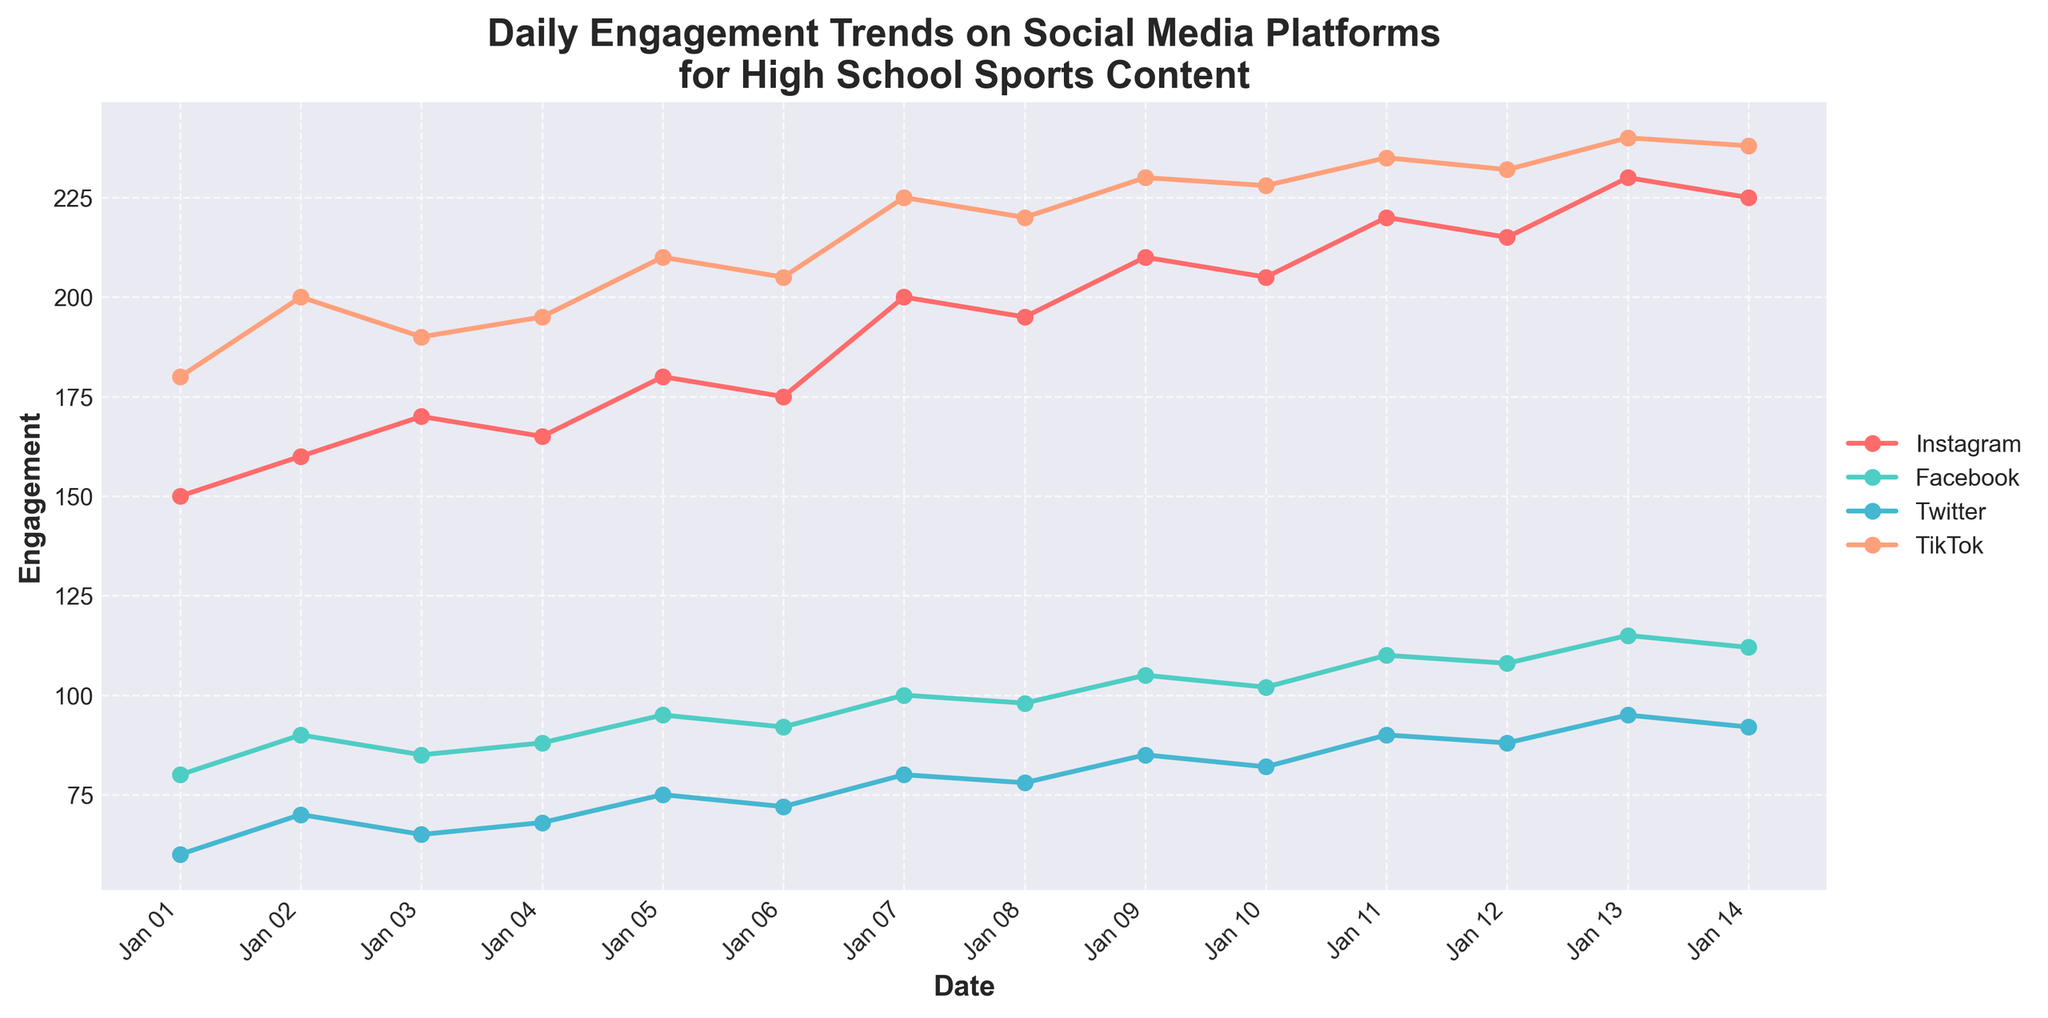What is the title of the plot? The title is prominently displayed at the top of the plot, indicating its overall subject matter.
Answer: Daily Engagement Trends on Social Media Platforms for High School Sports Content Which social media platform has the highest engagement on October 7, 2023? To find the highest engagement, locate October 7, 2023, on the x-axis and compare the engagement values for each platform on that date.
Answer: TikTok How many social media platforms are displayed in the plot? Count the distinct lines in the plot, each representing a different social media platform.
Answer: Four On which date did Instagram have the highest engagement, and what was the value? Identify the date where the Instagram engagement line reaches its peak and read the corresponding value.
Answer: October 13, 2023, with 230 engagements Compare Facebook engagement on October 1, 2023, and October 14, 2023. Which date had higher engagement, and by how much? Find the Facebook engagement values for both dates and subtract the value on October 1 from the value on October 14.
Answer: October 14, by 32 engagements What is the overall trend for Twitter engagement from October 1 to October 14, 2023? Observe the Twitter engagement line for changes from the start to the end of the date range.
Answer: Increasing trend Which platform had the most consistent engagement over the observed period? Look for the platform with minimal fluctuations in its engagement line across all dates.
Answer: Facebook Calculate the average TikTok engagement over the entire period. Add up all daily TikTok engagement values and divide by the number of days (14).
Answer: 215.07 Was there any date when the engagement for all platforms increased compared to the previous day? Check each date to see if the engagement values for Instagram, Facebook, Twitter, and TikTok are all higher than the previous day's values.
Answer: October 2, 2023 Between Instagram and TikTok, which platform had more fluctuations in engagement values? Compare the degree of change in engagement values day-to-day for both Instagram and TikTok.
Answer: TikTok 